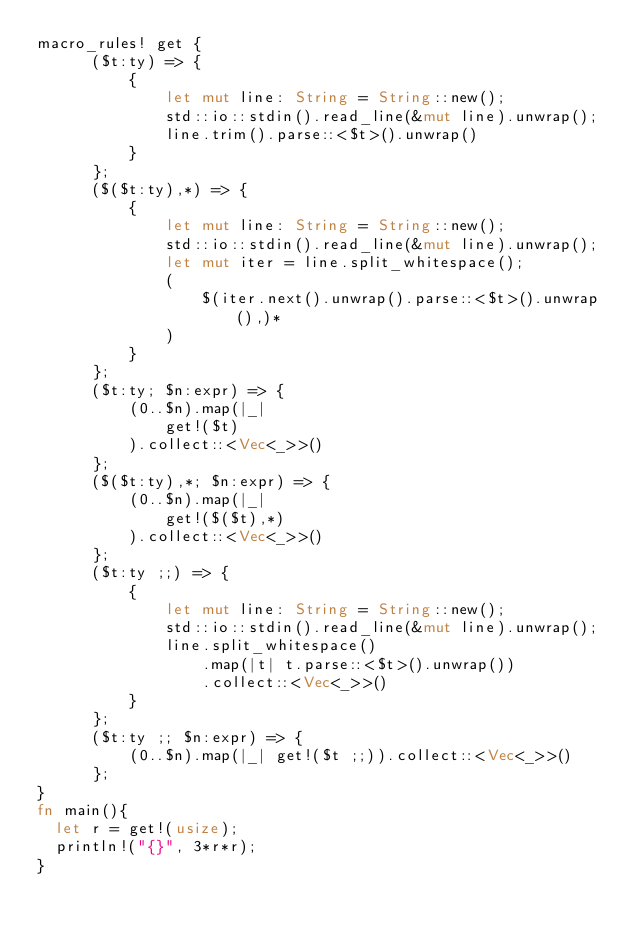Convert code to text. <code><loc_0><loc_0><loc_500><loc_500><_Rust_>macro_rules! get {
      ($t:ty) => {
          {
              let mut line: String = String::new();
              std::io::stdin().read_line(&mut line).unwrap();
              line.trim().parse::<$t>().unwrap()
          }
      };
      ($($t:ty),*) => {
          {
              let mut line: String = String::new();
              std::io::stdin().read_line(&mut line).unwrap();
              let mut iter = line.split_whitespace();
              (
                  $(iter.next().unwrap().parse::<$t>().unwrap(),)*
              )
          }
      };
      ($t:ty; $n:expr) => {
          (0..$n).map(|_|
              get!($t)
          ).collect::<Vec<_>>()
      };
      ($($t:ty),*; $n:expr) => {
          (0..$n).map(|_|
              get!($($t),*)
          ).collect::<Vec<_>>()
      };
      ($t:ty ;;) => {
          {
              let mut line: String = String::new();
              std::io::stdin().read_line(&mut line).unwrap();
              line.split_whitespace()
                  .map(|t| t.parse::<$t>().unwrap())
                  .collect::<Vec<_>>()
          }
      };
      ($t:ty ;; $n:expr) => {
          (0..$n).map(|_| get!($t ;;)).collect::<Vec<_>>()
      };
}
fn main(){
	let r = get!(usize);
	println!("{}", 3*r*r);
}</code> 